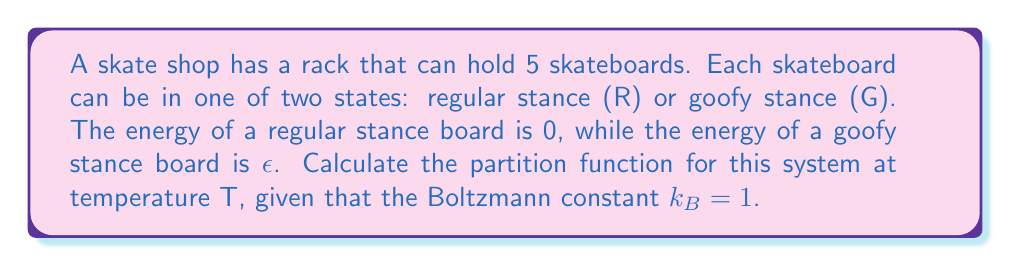Give your solution to this math problem. To solve this problem, we'll follow these steps:

1) The partition function Z is given by the sum over all possible microstates:

   $$ Z = \sum_i e^{-\beta E_i} $$

   where $\beta = \frac{1}{k_B T} = \frac{1}{T}$ (since $k_B = 1$)

2) In this case, each skateboard has two possible states (R or G), and there are 5 skateboards. So, the total number of microstates is $2^5 = 32$.

3) We need to consider all possible combinations of R and G, from 0 to 5 goofy stance boards:

   - 0 goofy (5R, 0G): $1 \cdot e^{-\beta \cdot 0} = 1$
   - 1 goofy (4R, 1G): $5 \cdot e^{-\beta \epsilon}$
   - 2 goofy (3R, 2G): $10 \cdot e^{-2\beta \epsilon}$
   - 3 goofy (2R, 3G): $10 \cdot e^{-3\beta \epsilon}$
   - 4 goofy (1R, 4G): $5 \cdot e^{-4\beta \epsilon}$
   - 5 goofy (0R, 5G): $1 \cdot e^{-5\beta \epsilon}$

4) The coefficients are given by the binomial coefficients $\binom{5}{k}$ where k is the number of goofy stance boards.

5) Summing all these terms gives us the partition function:

   $$ Z = 1 + 5e^{-\beta \epsilon} + 10e^{-2\beta \epsilon} + 10e^{-3\beta \epsilon} + 5e^{-4\beta \epsilon} + e^{-5\beta \epsilon} $$

6) This can be simplified using the binomial theorem:

   $$ Z = (1 + e^{-\beta \epsilon})^5 $$

7) Substituting $\beta = \frac{1}{T}$, we get our final expression:

   $$ Z = (1 + e^{-\epsilon/T})^5 $$
Answer: $Z = (1 + e^{-\epsilon/T})^5$ 